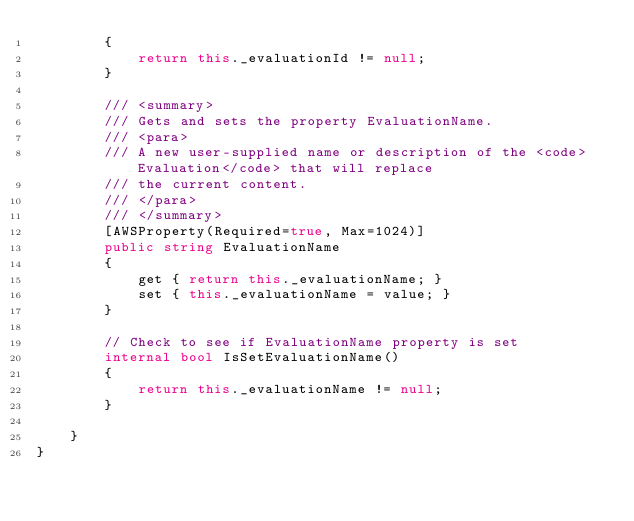Convert code to text. <code><loc_0><loc_0><loc_500><loc_500><_C#_>        {
            return this._evaluationId != null;
        }

        /// <summary>
        /// Gets and sets the property EvaluationName. 
        /// <para>
        /// A new user-supplied name or description of the <code>Evaluation</code> that will replace
        /// the current content. 
        /// </para>
        /// </summary>
        [AWSProperty(Required=true, Max=1024)]
        public string EvaluationName
        {
            get { return this._evaluationName; }
            set { this._evaluationName = value; }
        }

        // Check to see if EvaluationName property is set
        internal bool IsSetEvaluationName()
        {
            return this._evaluationName != null;
        }

    }
}</code> 